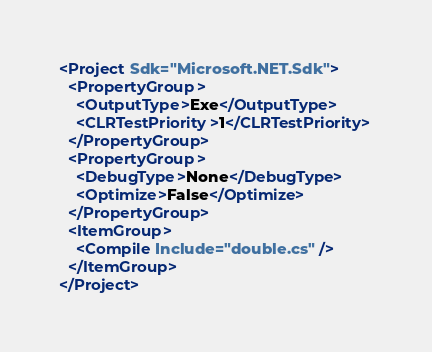<code> <loc_0><loc_0><loc_500><loc_500><_XML_><Project Sdk="Microsoft.NET.Sdk">
  <PropertyGroup>
    <OutputType>Exe</OutputType>
    <CLRTestPriority>1</CLRTestPriority>
  </PropertyGroup>
  <PropertyGroup>
    <DebugType>None</DebugType>
    <Optimize>False</Optimize>
  </PropertyGroup>
  <ItemGroup>
    <Compile Include="double.cs" />
  </ItemGroup>
</Project>
</code> 